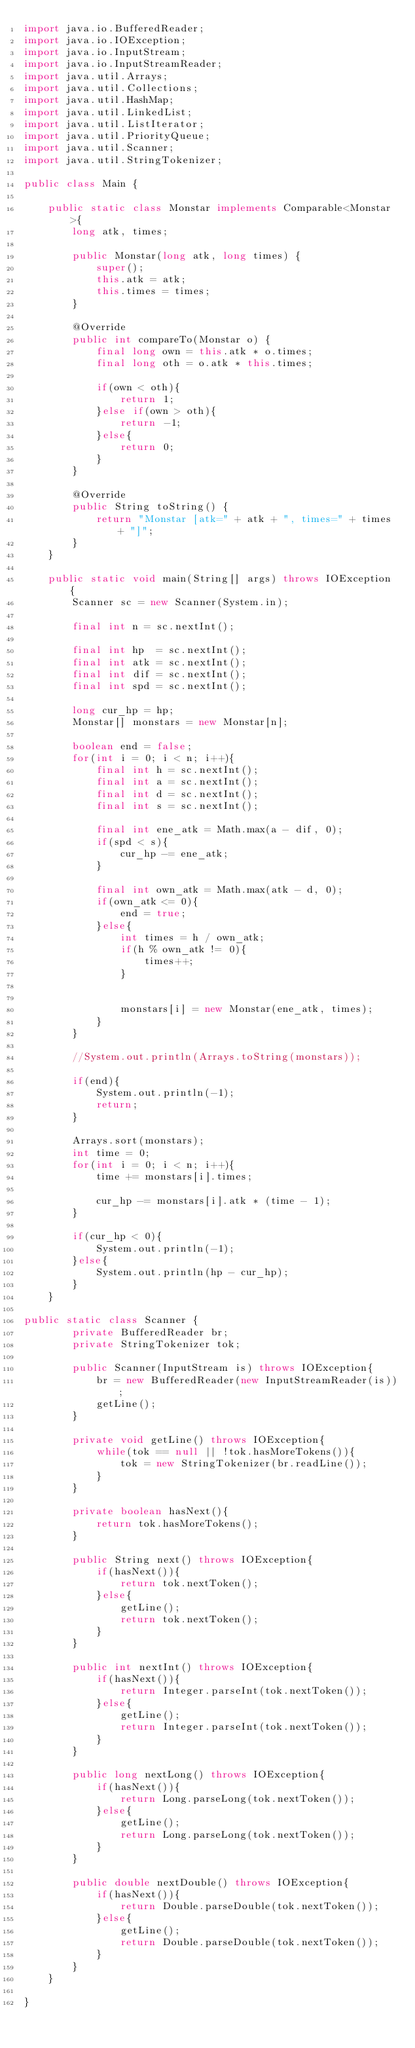<code> <loc_0><loc_0><loc_500><loc_500><_Java_>import java.io.BufferedReader;
import java.io.IOException;
import java.io.InputStream;
import java.io.InputStreamReader;
import java.util.Arrays;
import java.util.Collections;
import java.util.HashMap;
import java.util.LinkedList;
import java.util.ListIterator;
import java.util.PriorityQueue;
import java.util.Scanner;
import java.util.StringTokenizer;

public class Main {
	
	public static class Monstar implements Comparable<Monstar>{
		long atk, times;

		public Monstar(long atk, long times) {
			super();
			this.atk = atk;
			this.times = times;
		}

		@Override
		public int compareTo(Monstar o) {
			final long own = this.atk * o.times;
			final long oth = o.atk * this.times;
			
			if(own < oth){
				return 1;
			}else if(own > oth){
				return -1;
			}else{
				return 0;
			}
		}

		@Override
		public String toString() {
			return "Monstar [atk=" + atk + ", times=" + times + "]";
		}
	}
	
	public static void main(String[] args) throws IOException {
		Scanner sc = new Scanner(System.in);
		
		final int n = sc.nextInt();
		
		final int hp  = sc.nextInt();
		final int atk = sc.nextInt();
		final int dif = sc.nextInt();
		final int spd = sc.nextInt();
		
		long cur_hp = hp;
		Monstar[] monstars = new Monstar[n];
		
		boolean end = false;
		for(int i = 0; i < n; i++){
			final int h = sc.nextInt();
			final int a = sc.nextInt();
			final int d = sc.nextInt();
			final int s = sc.nextInt();
			
			final int ene_atk = Math.max(a - dif, 0);
			if(spd < s){
				cur_hp -= ene_atk;
			}
			
			final int own_atk = Math.max(atk - d, 0);
			if(own_atk <= 0){
				end = true;
			}else{
				int times = h / own_atk;
				if(h % own_atk != 0){
					times++;
				}
				
				
				monstars[i] = new Monstar(ene_atk, times);
			}
		}
		
		//System.out.println(Arrays.toString(monstars));
		
		if(end){
			System.out.println(-1);
			return;
		}
		
		Arrays.sort(monstars);
		int time = 0;
		for(int i = 0; i < n; i++){
			time += monstars[i].times;
			
			cur_hp -= monstars[i].atk * (time - 1);
		}
		
		if(cur_hp < 0){
			System.out.println(-1);
		}else{
			System.out.println(hp - cur_hp);
		}
	}
	
public static class Scanner {
		private BufferedReader br;
		private StringTokenizer tok;
		
		public Scanner(InputStream is) throws IOException{
			br = new BufferedReader(new InputStreamReader(is));
			getLine();
		}
		
		private void getLine() throws IOException{
			while(tok == null || !tok.hasMoreTokens()){
				tok = new StringTokenizer(br.readLine());
			}
		}
		
		private boolean hasNext(){
			return tok.hasMoreTokens();
		}
		
		public String next() throws IOException{
			if(hasNext()){
				return tok.nextToken();
			}else{
				getLine();
				return tok.nextToken();
			}
		}
		
		public int nextInt() throws IOException{
			if(hasNext()){
				return Integer.parseInt(tok.nextToken());
			}else{
				getLine();
				return Integer.parseInt(tok.nextToken());
			}
		}
		
		public long nextLong() throws IOException{
			if(hasNext()){
				return Long.parseLong(tok.nextToken());
			}else{
				getLine();
				return Long.parseLong(tok.nextToken());
			}
		}
		
		public double nextDouble() throws IOException{
			if(hasNext()){
				return Double.parseDouble(tok.nextToken());
			}else{
				getLine();
				return Double.parseDouble(tok.nextToken());
			}
		}
	}

}</code> 